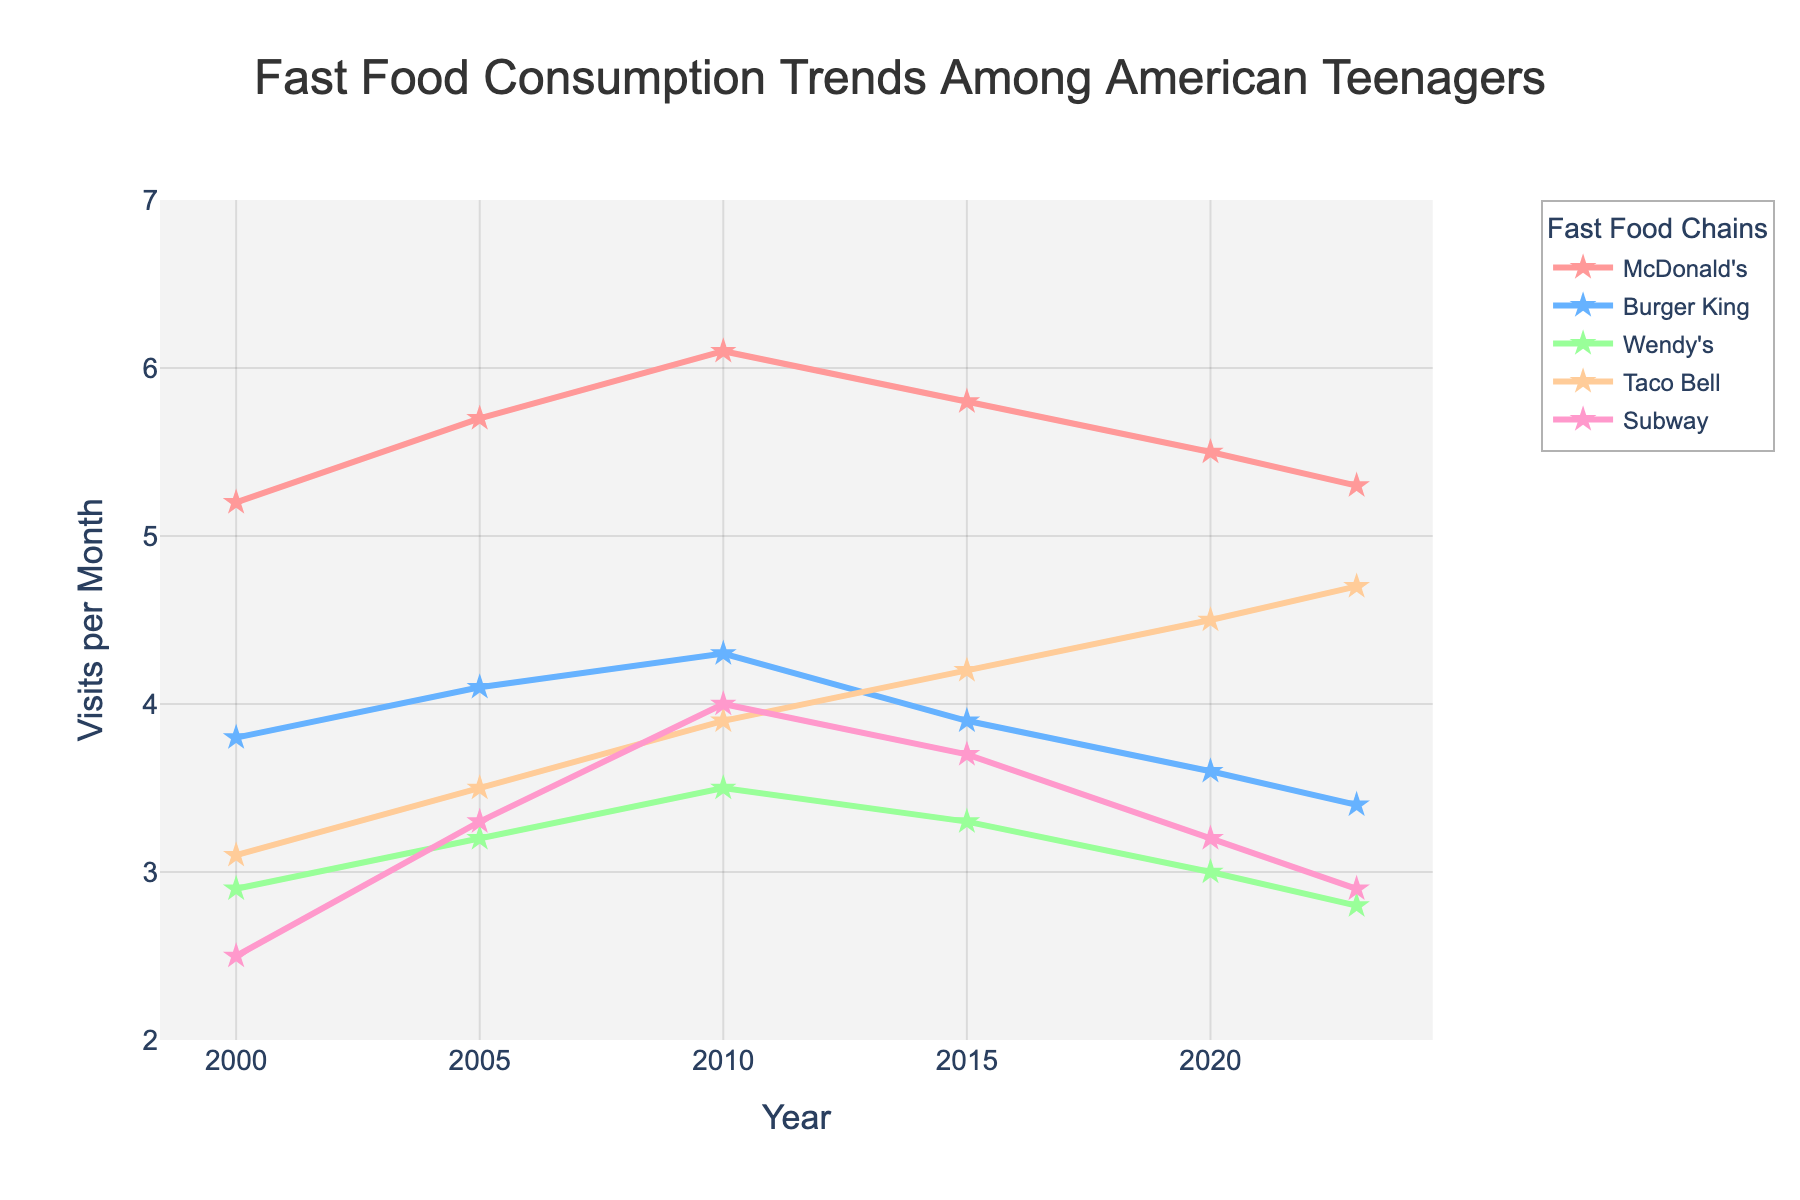What is the general trend for McDonald's visits from 2000 to 2023? To determine this, look at the positions of the markers for McDonald's along the y-axis over the years. Starting from 2000, the values increase up to 2010, then decrease slightly towards 2023. This indicates an overall slight increase followed by a mild decline.
Answer: Slight increase followed by a mild decline Which fast food chain saw the highest increase in visits from 2000 to 2010? Look at the lines for all fast food chains from 2000 to 2010 and compare the changes in y-axis values. McDonald's increased from 5.2 to 6.1, Burger King from 3.8 to 4.3, Wendy's from 2.9 to 3.5, Taco Bell from 3.1 to 3.9, and Subway from 2.5 to 4.0. Subway shows the highest increase.
Answer: Subway By how much did Taco Bell visits increase between 2000 and 2023? Look at Taco Bell's position on the y-axis for 2000 and 2023. In 2000, Taco Bell had 3.1 visits per month, and in 2023, it had 4.7 visits per month. Subtract the 2000 value from the 2023 value: 4.7 - 3.1 = 1.6.
Answer: 1.6 Which fast food chain had the smallest change in visits per month from 2000 to 2023? Analyze the beginning and ending points for each line to determine the change. McDonald's changes from 5.2 to 5.3 (0.1), Burger King from 3.8 to 3.4 (0.4), Wendy's from 2.9 to 2.8 (0.1), Taco Bell from 3.1 to 4.7 (1.6), and Subway from 2.5 to 2.9 (0.4). Wendy's had the smallest change.
Answer: Wendy's In what year did McDonald's have the highest number of visits? Check the highest point along the McDonald's line. The peak is reached in 2010, where the visits per month are 6.1.
Answer: 2010 Which two chains had the most similar number of visits in 2023? Compare the y-axis values of all chains in 2023. McDonald's has 5.3, Burger King has 3.4, Wendy's has 2.8, Taco Bell has 4.7, and Subway has 2.9. Wendy's and Subway have the closest values, 2.8 and 2.9 respectively.
Answer: Wendy's and Subway What was the average number of visits per month for McDonald's from 2000 to 2023? Sum the visits for McDonald's over the years: 5.2+5.7+6.1+5.8+5.5+5.3 = 33.6. Divide by the number of data points (6): 33.6 / 6 = 5.6.
Answer: 5.6 Which fast food chain shows a consistently increasing trend over the period? Observe the overall direction of the lines for each chain. All chains except Subway show some fluctuation, whereas Subway generally increases until 2010 and then decreases afterwards. Although Subway's trend is not perfectly consistent, it shows the most overall growth in early years.
Answer: None 